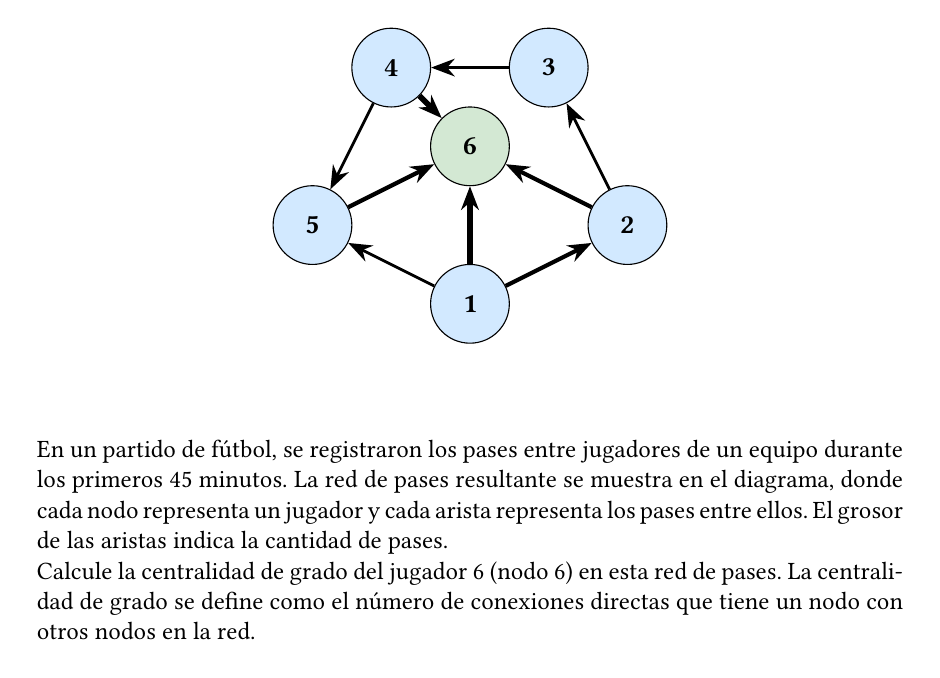Solve this math problem. Para calcular la centralidad de grado del jugador 6 (nodo 6), seguiremos estos pasos:

1) La centralidad de grado de un nodo se define como el número de conexiones directas que tiene con otros nodos en la red.

2) Observando el diagrama, vemos que el nodo 6 está conectado directamente a:
   - Nodo 1
   - Nodo 2
   - Nodo 3
   - Nodo 4
   - Nodo 5

3) Contamos el número de estas conexiones directas:

   $$\text{Centralidad de grado} = 5$$

4) Es importante notar que en este cálculo no consideramos el grosor de las aristas (que representa la cantidad de pases), sino solo la existencia de una conexión directa.

5) La centralidad de grado nos da una idea de qué tan involucrado está el jugador 6 en el juego en términos de intercambios de pases con otros jugadores.

Por lo tanto, la centralidad de grado del jugador 6 es 5, lo que sugiere que este jugador tiene un papel central en la red de pases del equipo, conectándose directamente con todos los demás jugadores representados en la red.
Answer: 5 